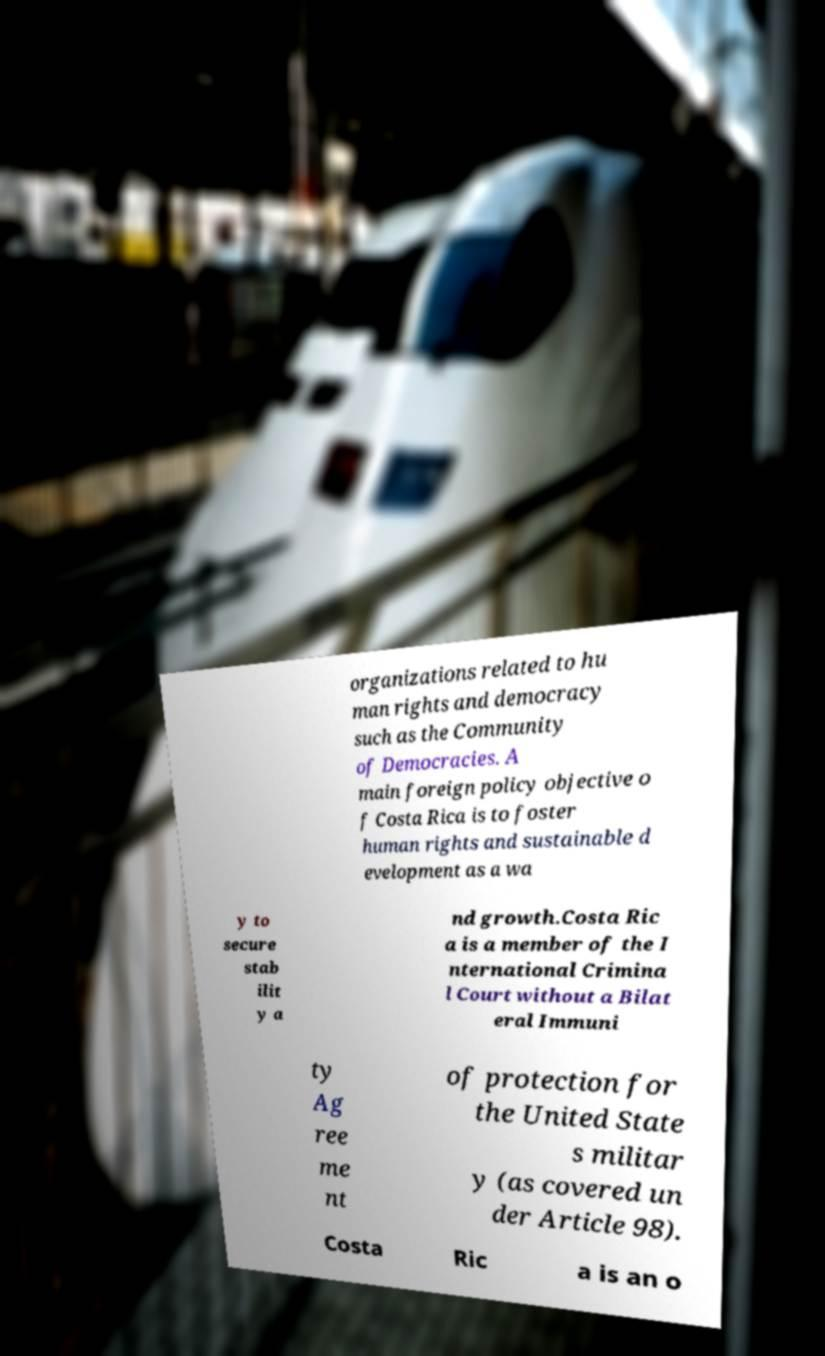Could you extract and type out the text from this image? organizations related to hu man rights and democracy such as the Community of Democracies. A main foreign policy objective o f Costa Rica is to foster human rights and sustainable d evelopment as a wa y to secure stab ilit y a nd growth.Costa Ric a is a member of the I nternational Crimina l Court without a Bilat eral Immuni ty Ag ree me nt of protection for the United State s militar y (as covered un der Article 98). Costa Ric a is an o 